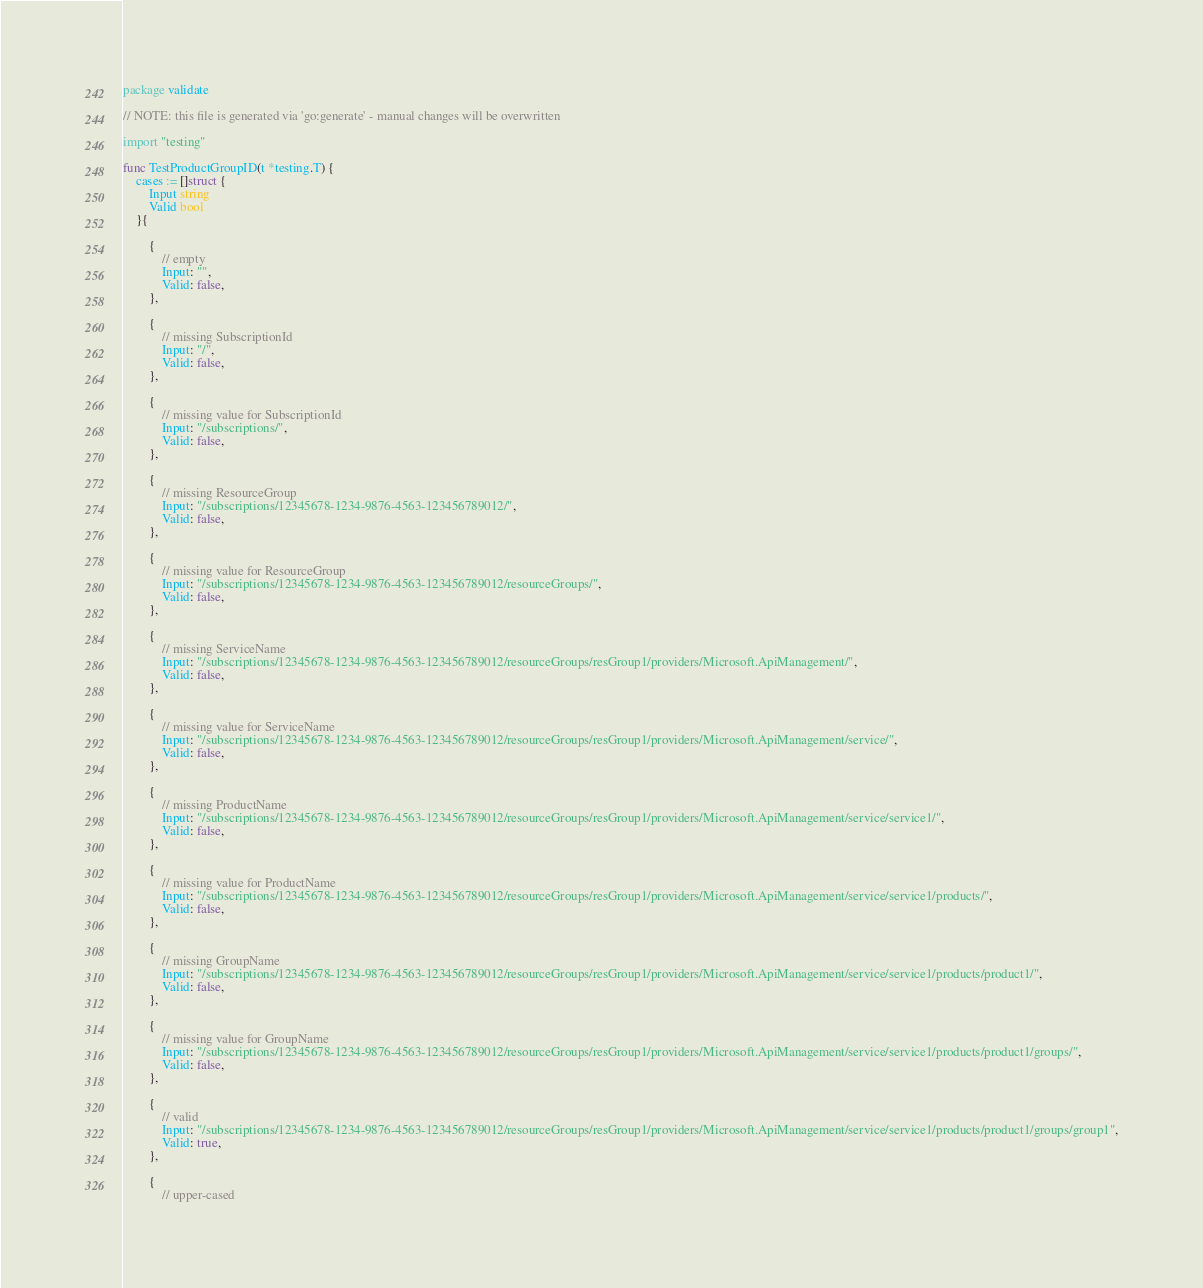Convert code to text. <code><loc_0><loc_0><loc_500><loc_500><_Go_>package validate

// NOTE: this file is generated via 'go:generate' - manual changes will be overwritten

import "testing"

func TestProductGroupID(t *testing.T) {
	cases := []struct {
		Input string
		Valid bool
	}{

		{
			// empty
			Input: "",
			Valid: false,
		},

		{
			// missing SubscriptionId
			Input: "/",
			Valid: false,
		},

		{
			// missing value for SubscriptionId
			Input: "/subscriptions/",
			Valid: false,
		},

		{
			// missing ResourceGroup
			Input: "/subscriptions/12345678-1234-9876-4563-123456789012/",
			Valid: false,
		},

		{
			// missing value for ResourceGroup
			Input: "/subscriptions/12345678-1234-9876-4563-123456789012/resourceGroups/",
			Valid: false,
		},

		{
			// missing ServiceName
			Input: "/subscriptions/12345678-1234-9876-4563-123456789012/resourceGroups/resGroup1/providers/Microsoft.ApiManagement/",
			Valid: false,
		},

		{
			// missing value for ServiceName
			Input: "/subscriptions/12345678-1234-9876-4563-123456789012/resourceGroups/resGroup1/providers/Microsoft.ApiManagement/service/",
			Valid: false,
		},

		{
			// missing ProductName
			Input: "/subscriptions/12345678-1234-9876-4563-123456789012/resourceGroups/resGroup1/providers/Microsoft.ApiManagement/service/service1/",
			Valid: false,
		},

		{
			// missing value for ProductName
			Input: "/subscriptions/12345678-1234-9876-4563-123456789012/resourceGroups/resGroup1/providers/Microsoft.ApiManagement/service/service1/products/",
			Valid: false,
		},

		{
			// missing GroupName
			Input: "/subscriptions/12345678-1234-9876-4563-123456789012/resourceGroups/resGroup1/providers/Microsoft.ApiManagement/service/service1/products/product1/",
			Valid: false,
		},

		{
			// missing value for GroupName
			Input: "/subscriptions/12345678-1234-9876-4563-123456789012/resourceGroups/resGroup1/providers/Microsoft.ApiManagement/service/service1/products/product1/groups/",
			Valid: false,
		},

		{
			// valid
			Input: "/subscriptions/12345678-1234-9876-4563-123456789012/resourceGroups/resGroup1/providers/Microsoft.ApiManagement/service/service1/products/product1/groups/group1",
			Valid: true,
		},

		{
			// upper-cased</code> 